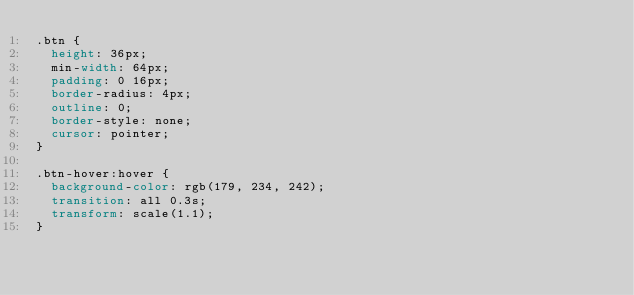Convert code to text. <code><loc_0><loc_0><loc_500><loc_500><_CSS_>.btn {
  height: 36px;
  min-width: 64px;
  padding: 0 16px;
  border-radius: 4px;
  outline: 0;
  border-style: none;
  cursor: pointer;
}

.btn-hover:hover {
  background-color: rgb(179, 234, 242);
  transition: all 0.3s;
  transform: scale(1.1);
}
</code> 